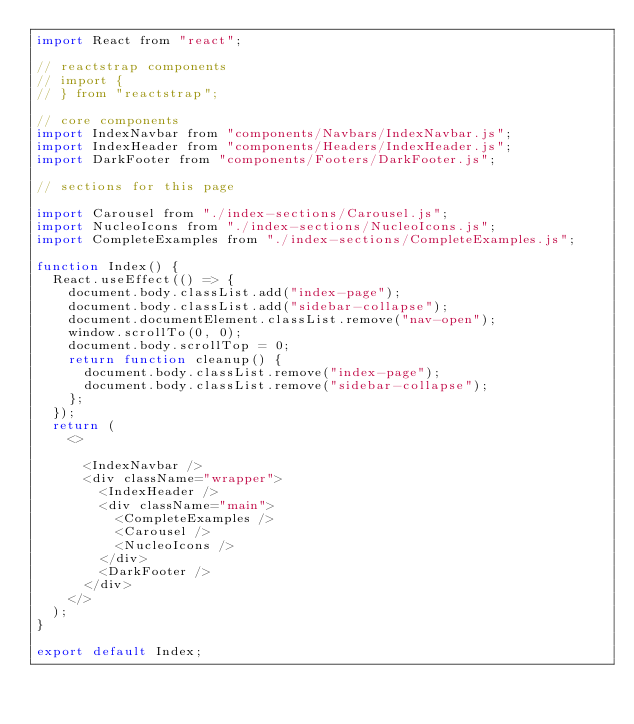Convert code to text. <code><loc_0><loc_0><loc_500><loc_500><_JavaScript_>import React from "react";

// reactstrap components
// import {
// } from "reactstrap";

// core components
import IndexNavbar from "components/Navbars/IndexNavbar.js";
import IndexHeader from "components/Headers/IndexHeader.js";
import DarkFooter from "components/Footers/DarkFooter.js";

// sections for this page

import Carousel from "./index-sections/Carousel.js";
import NucleoIcons from "./index-sections/NucleoIcons.js";
import CompleteExamples from "./index-sections/CompleteExamples.js";

function Index() {
  React.useEffect(() => {
    document.body.classList.add("index-page");
    document.body.classList.add("sidebar-collapse");
    document.documentElement.classList.remove("nav-open");
    window.scrollTo(0, 0);
    document.body.scrollTop = 0;
    return function cleanup() {
      document.body.classList.remove("index-page");
      document.body.classList.remove("sidebar-collapse");
    };
  });
  return (
    <>  
      
      <IndexNavbar />
      <div className="wrapper">
        <IndexHeader />
        <div className="main">
          <CompleteExamples />
          <Carousel />
          <NucleoIcons />
        </div>
        <DarkFooter />
      </div>
    </>
  );
}

export default Index;
</code> 